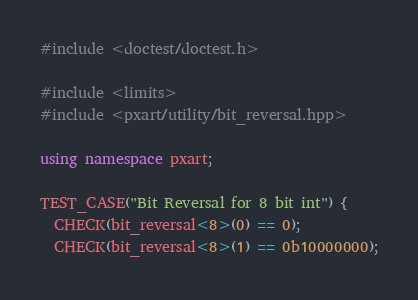<code> <loc_0><loc_0><loc_500><loc_500><_C++_>#include <doctest/doctest.h>

#include <limits>
#include <pxart/utility/bit_reversal.hpp>

using namespace pxart;

TEST_CASE("Bit Reversal for 8 bit int") {
  CHECK(bit_reversal<8>(0) == 0);
  CHECK(bit_reversal<8>(1) == 0b10000000);</code> 